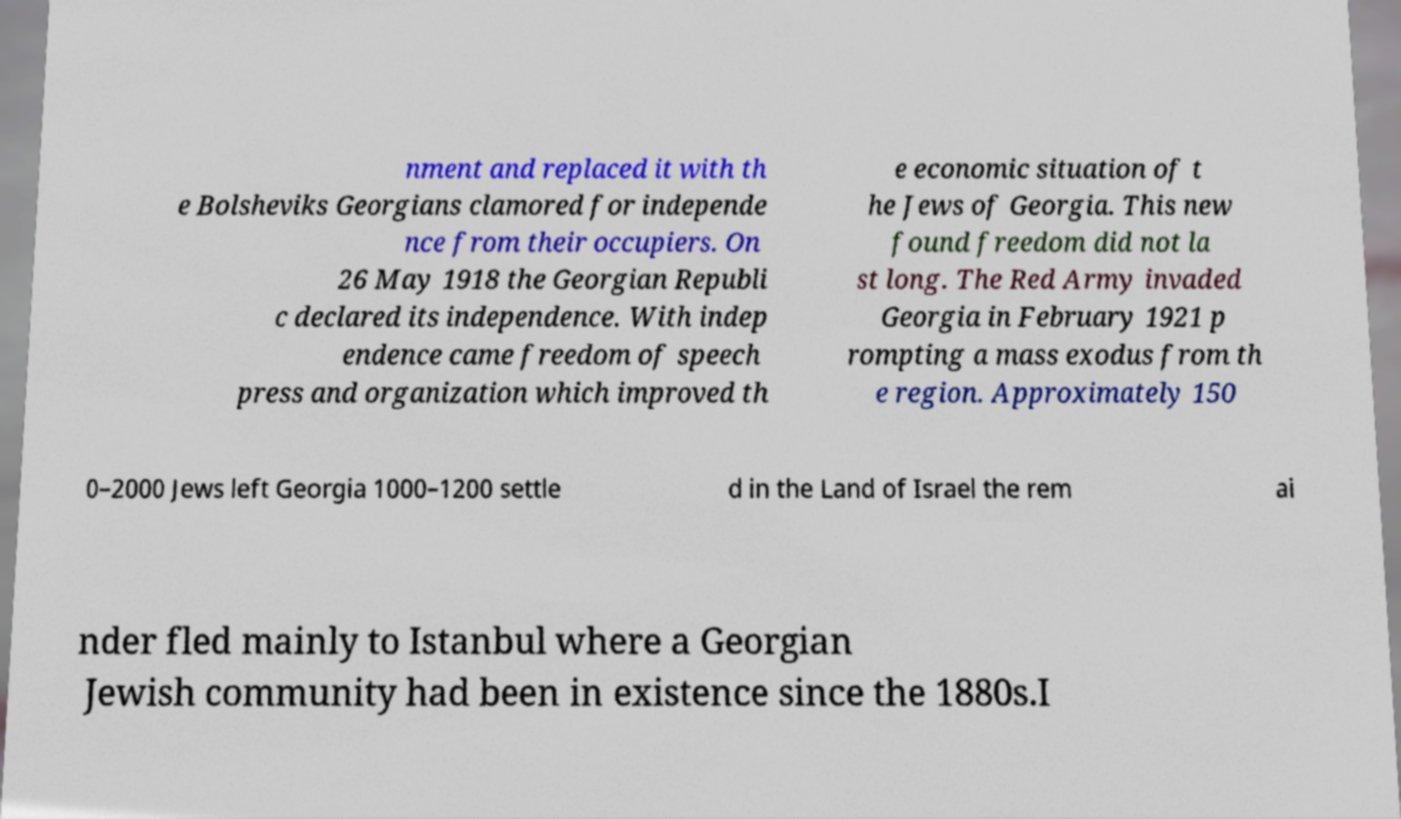Please identify and transcribe the text found in this image. nment and replaced it with th e Bolsheviks Georgians clamored for independe nce from their occupiers. On 26 May 1918 the Georgian Republi c declared its independence. With indep endence came freedom of speech press and organization which improved th e economic situation of t he Jews of Georgia. This new found freedom did not la st long. The Red Army invaded Georgia in February 1921 p rompting a mass exodus from th e region. Approximately 150 0–2000 Jews left Georgia 1000–1200 settle d in the Land of Israel the rem ai nder fled mainly to Istanbul where a Georgian Jewish community had been in existence since the 1880s.I 